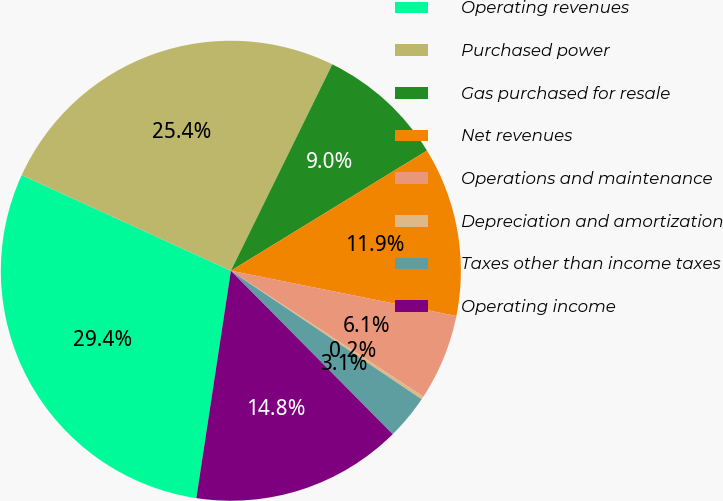Convert chart. <chart><loc_0><loc_0><loc_500><loc_500><pie_chart><fcel>Operating revenues<fcel>Purchased power<fcel>Gas purchased for resale<fcel>Net revenues<fcel>Operations and maintenance<fcel>Depreciation and amortization<fcel>Taxes other than income taxes<fcel>Operating income<nl><fcel>29.42%<fcel>25.44%<fcel>8.98%<fcel>11.9%<fcel>6.06%<fcel>0.22%<fcel>3.14%<fcel>14.82%<nl></chart> 